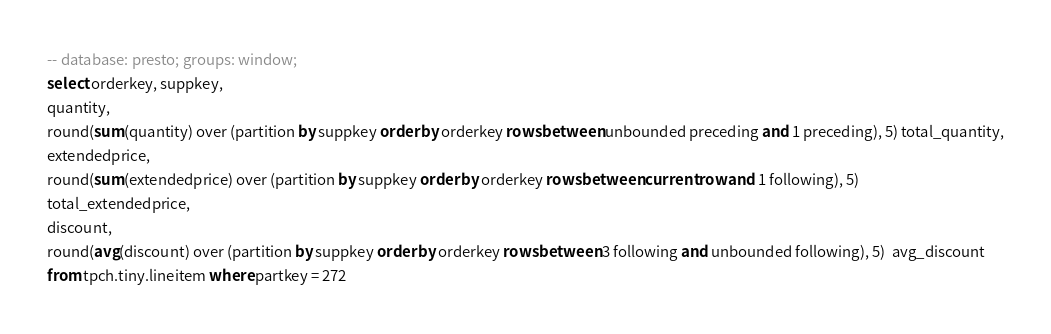Convert code to text. <code><loc_0><loc_0><loc_500><loc_500><_SQL_>-- database: presto; groups: window;
select orderkey, suppkey,
quantity,
round(sum(quantity) over (partition by suppkey order by orderkey rows between unbounded preceding and 1 preceding), 5) total_quantity,
extendedprice,
round(sum(extendedprice) over (partition by suppkey order by orderkey rows between current row and 1 following), 5)
total_extendedprice,
discount,
round(avg(discount) over (partition by suppkey order by orderkey rows between 3 following and unbounded following), 5)  avg_discount
from tpch.tiny.lineitem where partkey = 272
</code> 